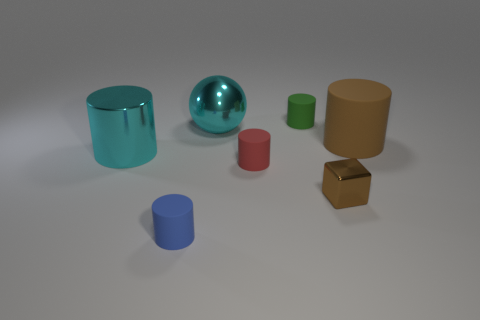Subtract all green cylinders. How many cylinders are left? 4 Subtract all red cylinders. How many cylinders are left? 4 Add 1 tiny yellow spheres. How many objects exist? 8 Add 5 big brown matte cylinders. How many big brown matte cylinders are left? 6 Add 3 small blue things. How many small blue things exist? 4 Subtract 0 yellow spheres. How many objects are left? 7 Subtract all cylinders. How many objects are left? 2 Subtract all purple cylinders. Subtract all red blocks. How many cylinders are left? 5 Subtract all blue balls. How many red cylinders are left? 1 Subtract all small blue objects. Subtract all yellow rubber cylinders. How many objects are left? 6 